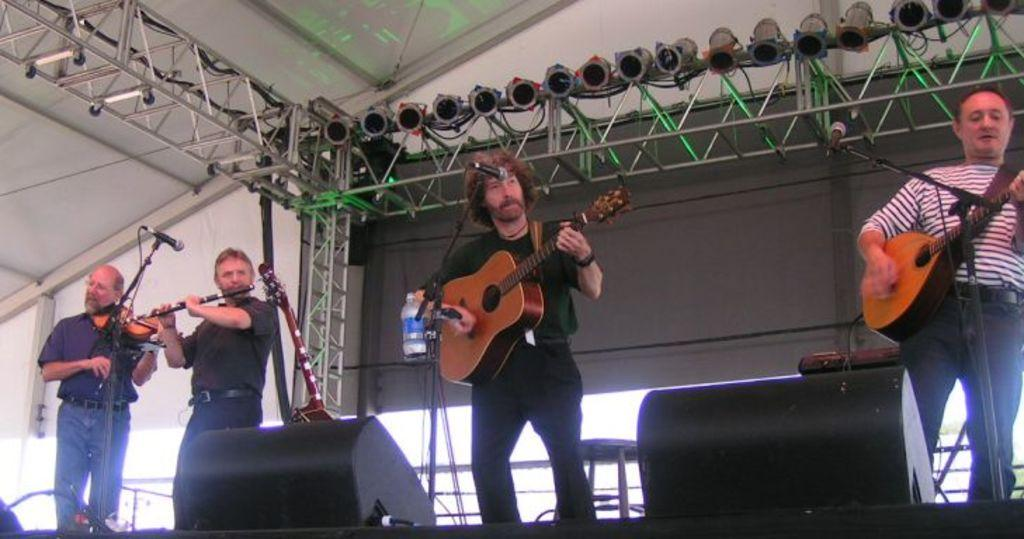How many people are in the image? There are four men in the image. What are the men doing in the image? The men are playing musical instruments. Can you describe any objects in the image besides the musical instruments? Yes, there is a bottle and a microphone (mic) in the image. What type of tub can be seen in the image? There is no tub present in the image. How many mice are playing musical instruments in the image? There are no mice in the image; the musicians are all men. 